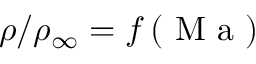Convert formula to latex. <formula><loc_0><loc_0><loc_500><loc_500>\rho / \rho _ { \infty } = f \left ( M a \right )</formula> 